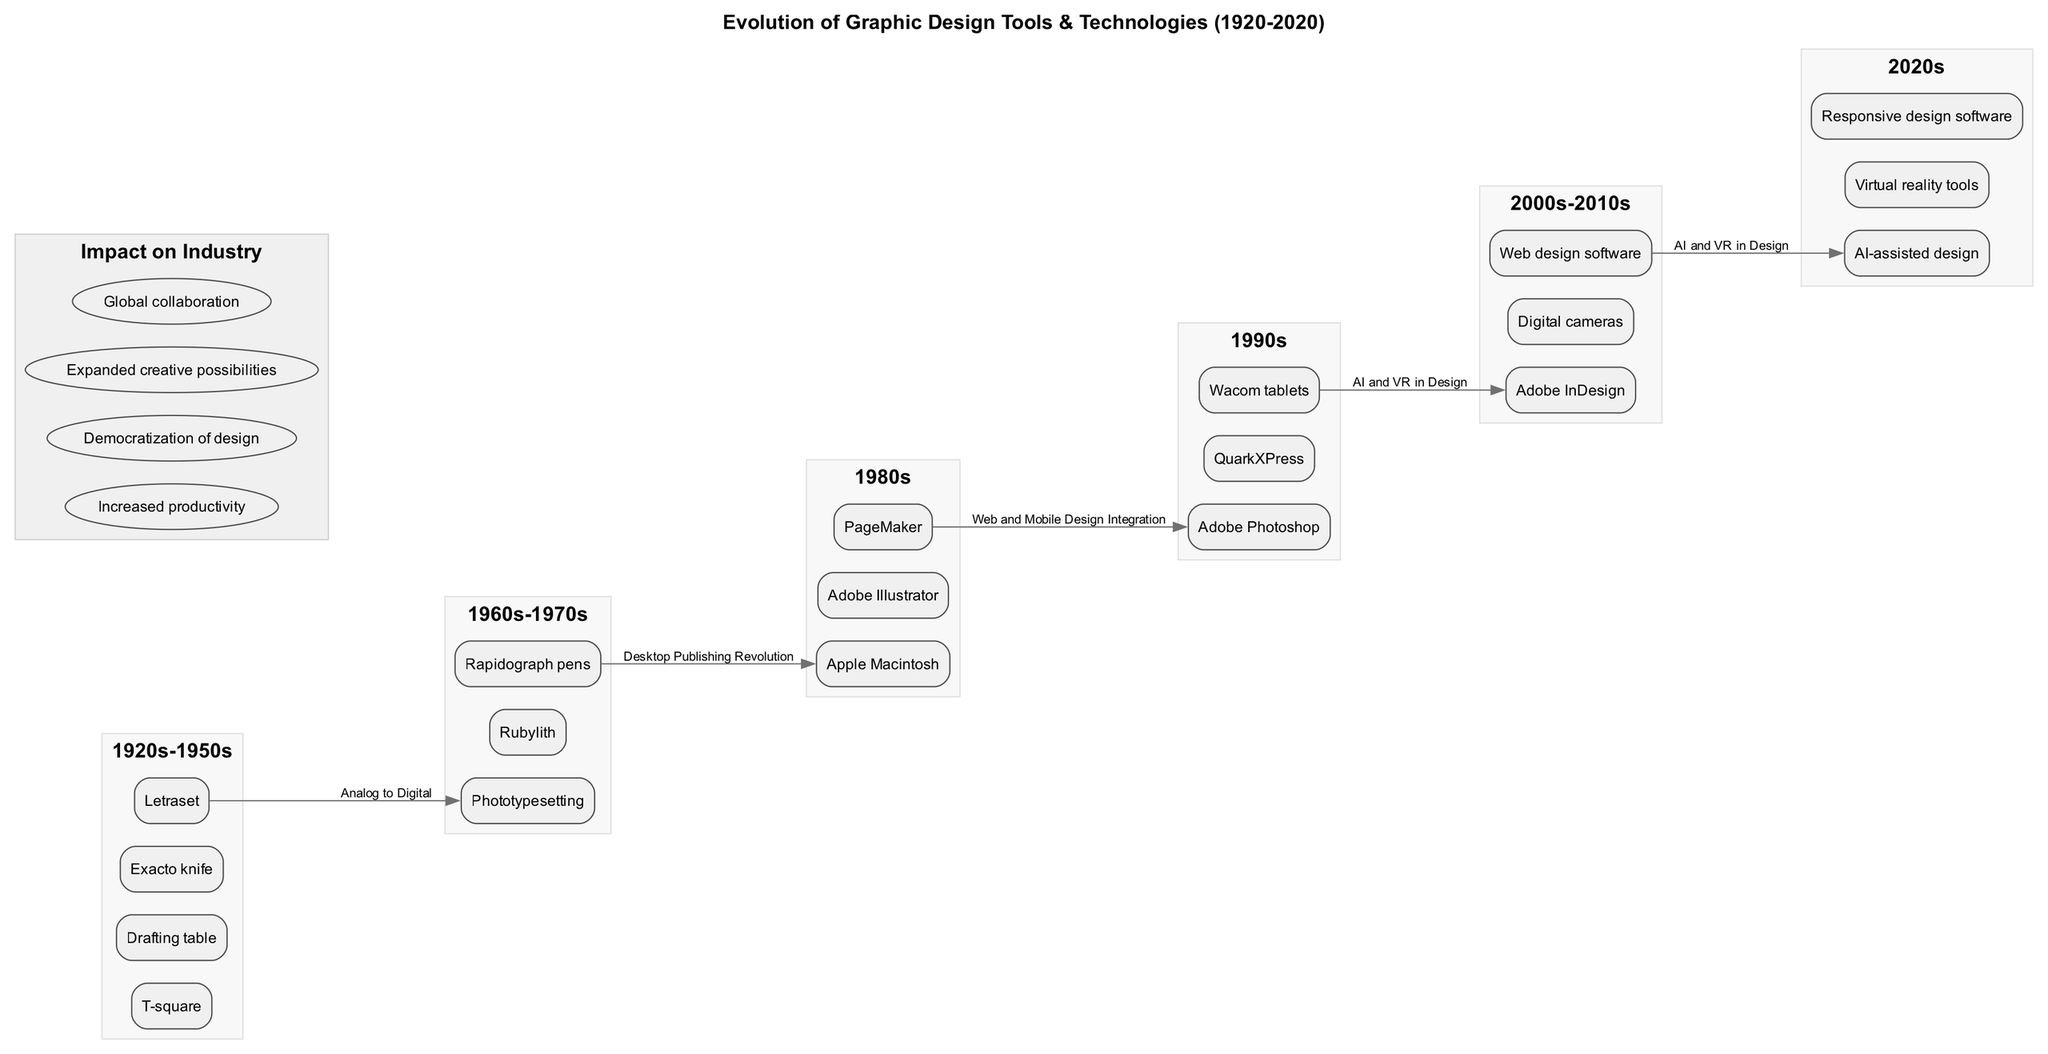What tools were used in the 1980s? The diagram lists the tools in the 1980s era, which include Apple Macintosh, Adobe Illustrator, and PageMaker.
Answer: Apple Macintosh, Adobe Illustrator, PageMaker How many key transitions are noted in the infographic? The diagram specifies four key transitions. By counting the items listed under "key transitions", we find there are four distinct transitions.
Answer: 4 What is the impact of design tools on industry during the 2000s-2010s? The infographic shows various impacts on the industry, but for the 2000s-2010s period, the diagram focuses on increased productivity, democratization of design, expanded creative possibilities, and global collaboration, which are all relevant in this time frame.
Answer: Increased productivity, democratization of design, expanded creative possibilities, global collaboration Which era introduced AI-assisted design tools? By examining the timeline, the era labeled "2020s" includes the introduction of AI-assisted design tools, indicating that this was the era when such technologies were incorporated in the graphic design field.
Answer: 2020s What tools transitioned from analog to digital? Referring to the key transitions, the transition from analog to digital is specific to the 1980s tools listed in the infographic, which includes Apple Macintosh, Adobe Illustrator, and PageMaker, as they represent major technological advancements that shifted design from traditional methods to digital formats.
Answer: Apple Macintosh, Adobe Illustrator, PageMaker In which era were Wacom tablets introduced? The diagram indicates that Wacom tablets were introduced in the 1990s. By checking the timeline and the tools listed, we see Wacom tablets are listed under the 1990s section, confirming their introduction during this period.
Answer: 1990s What is the first tool listed in the 1960s-1970s era? In the timeline for the 1960s-1970s era, the first tool mentioned is Phototypesetting. By reviewing the tools under this section, Phototypesetting is explicitly listed first.
Answer: Phototypesetting How many tools are listed for the 1920s-1950s era? The infographic reveals that there are four tools in the 1920s-1950s era: T-square, Drafting table, Exacto knife, and Letraset, indicating a total of four tools available during this period.
Answer: 4 What marked the Desktop Publishing Revolution? By consulting the key transitions part of the diagram, we see "Desktop Publishing Revolution" explicitly mentioned, signifying the transition where graphic design began to incorporate desktop publishing technologies, notably in the 1980s.
Answer: Desktop Publishing Revolution 